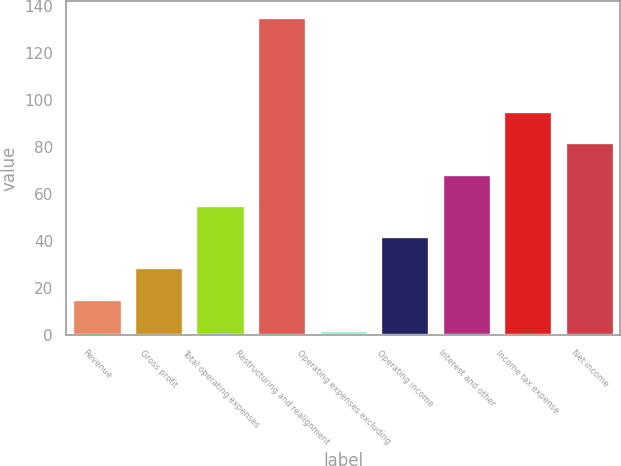Convert chart to OTSL. <chart><loc_0><loc_0><loc_500><loc_500><bar_chart><fcel>Revenue<fcel>Gross profit<fcel>Total operating expenses<fcel>Restructuring and realignment<fcel>Operating expenses excluding<fcel>Operating income<fcel>Interest and other<fcel>Income tax expense<fcel>Net income<nl><fcel>15.48<fcel>28.76<fcel>55.32<fcel>135<fcel>2.2<fcel>42.04<fcel>68.6<fcel>95.16<fcel>81.88<nl></chart> 